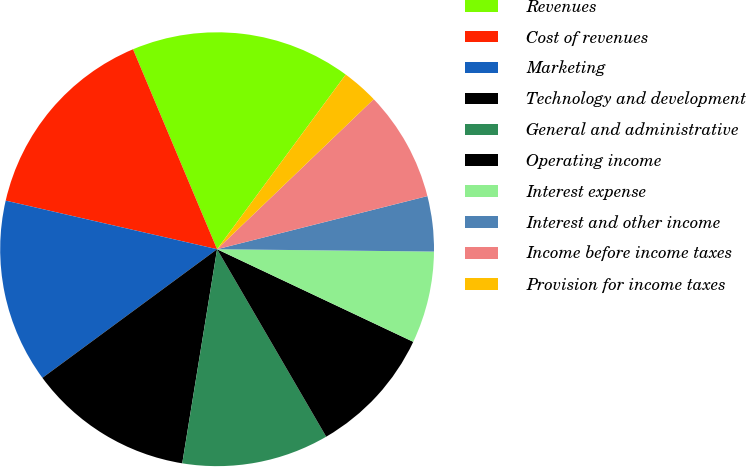<chart> <loc_0><loc_0><loc_500><loc_500><pie_chart><fcel>Revenues<fcel>Cost of revenues<fcel>Marketing<fcel>Technology and development<fcel>General and administrative<fcel>Operating income<fcel>Interest expense<fcel>Interest and other income<fcel>Income before income taxes<fcel>Provision for income taxes<nl><fcel>16.44%<fcel>15.07%<fcel>13.7%<fcel>12.33%<fcel>10.96%<fcel>9.59%<fcel>6.85%<fcel>4.11%<fcel>8.22%<fcel>2.74%<nl></chart> 